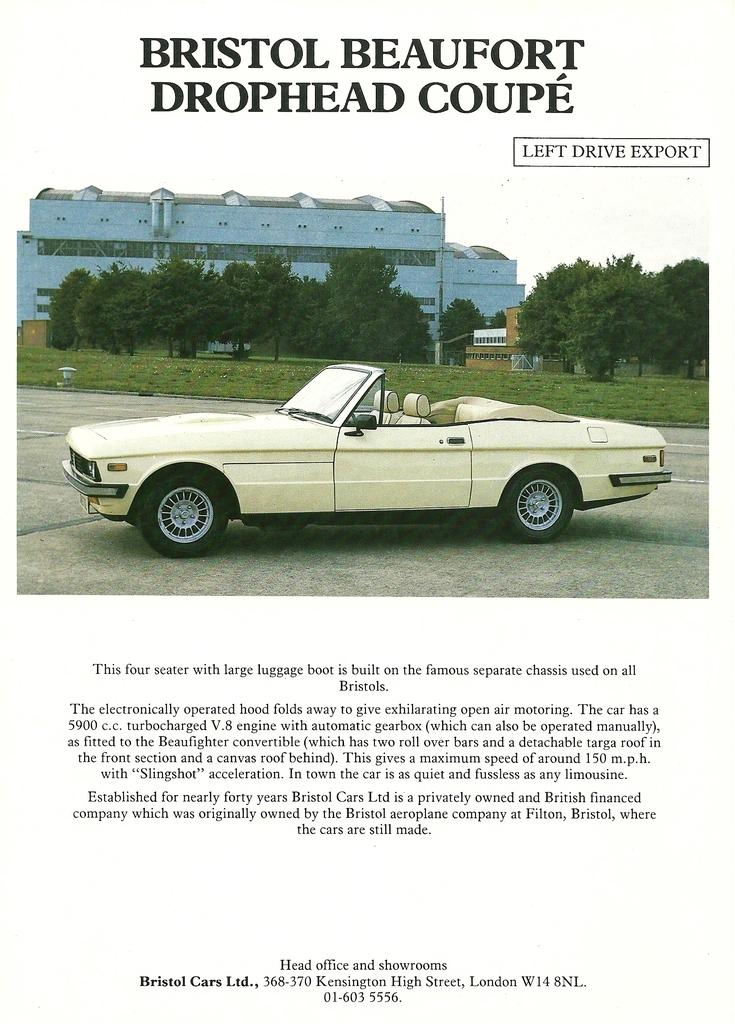What is depicted on the poster in the image? The poster contains a car, trees, buildings, and text. Can you describe the setting of the poster? The poster features a car, trees, and buildings, which suggests an urban or suburban environment. What type of information might be conveyed by the text on the poster? The text on the poster could provide information about the car, the environment, or a related topic. Can you describe the dog that is touching the poster in the image? There is no dog present in the image, nor is there any indication that a dog has touched the poster. 